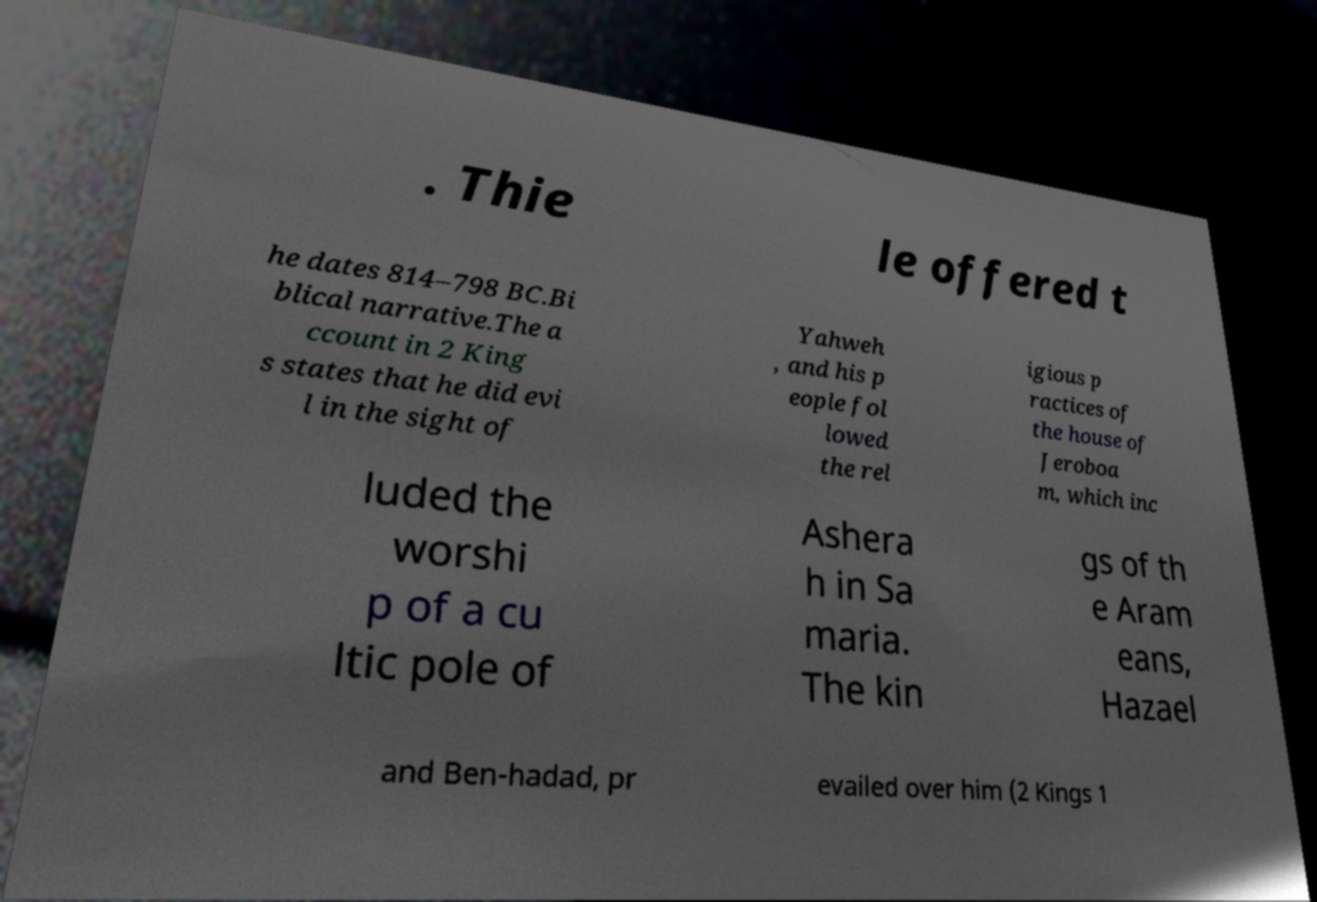For documentation purposes, I need the text within this image transcribed. Could you provide that? . Thie le offered t he dates 814–798 BC.Bi blical narrative.The a ccount in 2 King s states that he did evi l in the sight of Yahweh , and his p eople fol lowed the rel igious p ractices of the house of Jeroboa m, which inc luded the worshi p of a cu ltic pole of Ashera h in Sa maria. The kin gs of th e Aram eans, Hazael and Ben-hadad, pr evailed over him (2 Kings 1 